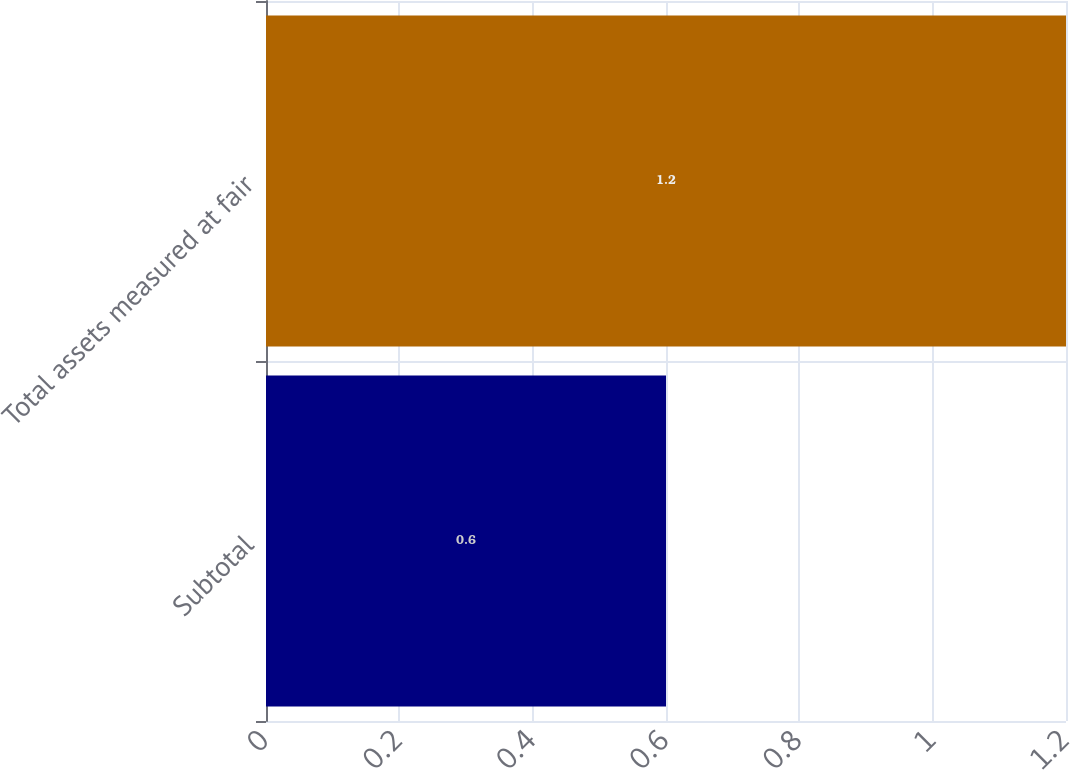Convert chart. <chart><loc_0><loc_0><loc_500><loc_500><bar_chart><fcel>Subtotal<fcel>Total assets measured at fair<nl><fcel>0.6<fcel>1.2<nl></chart> 